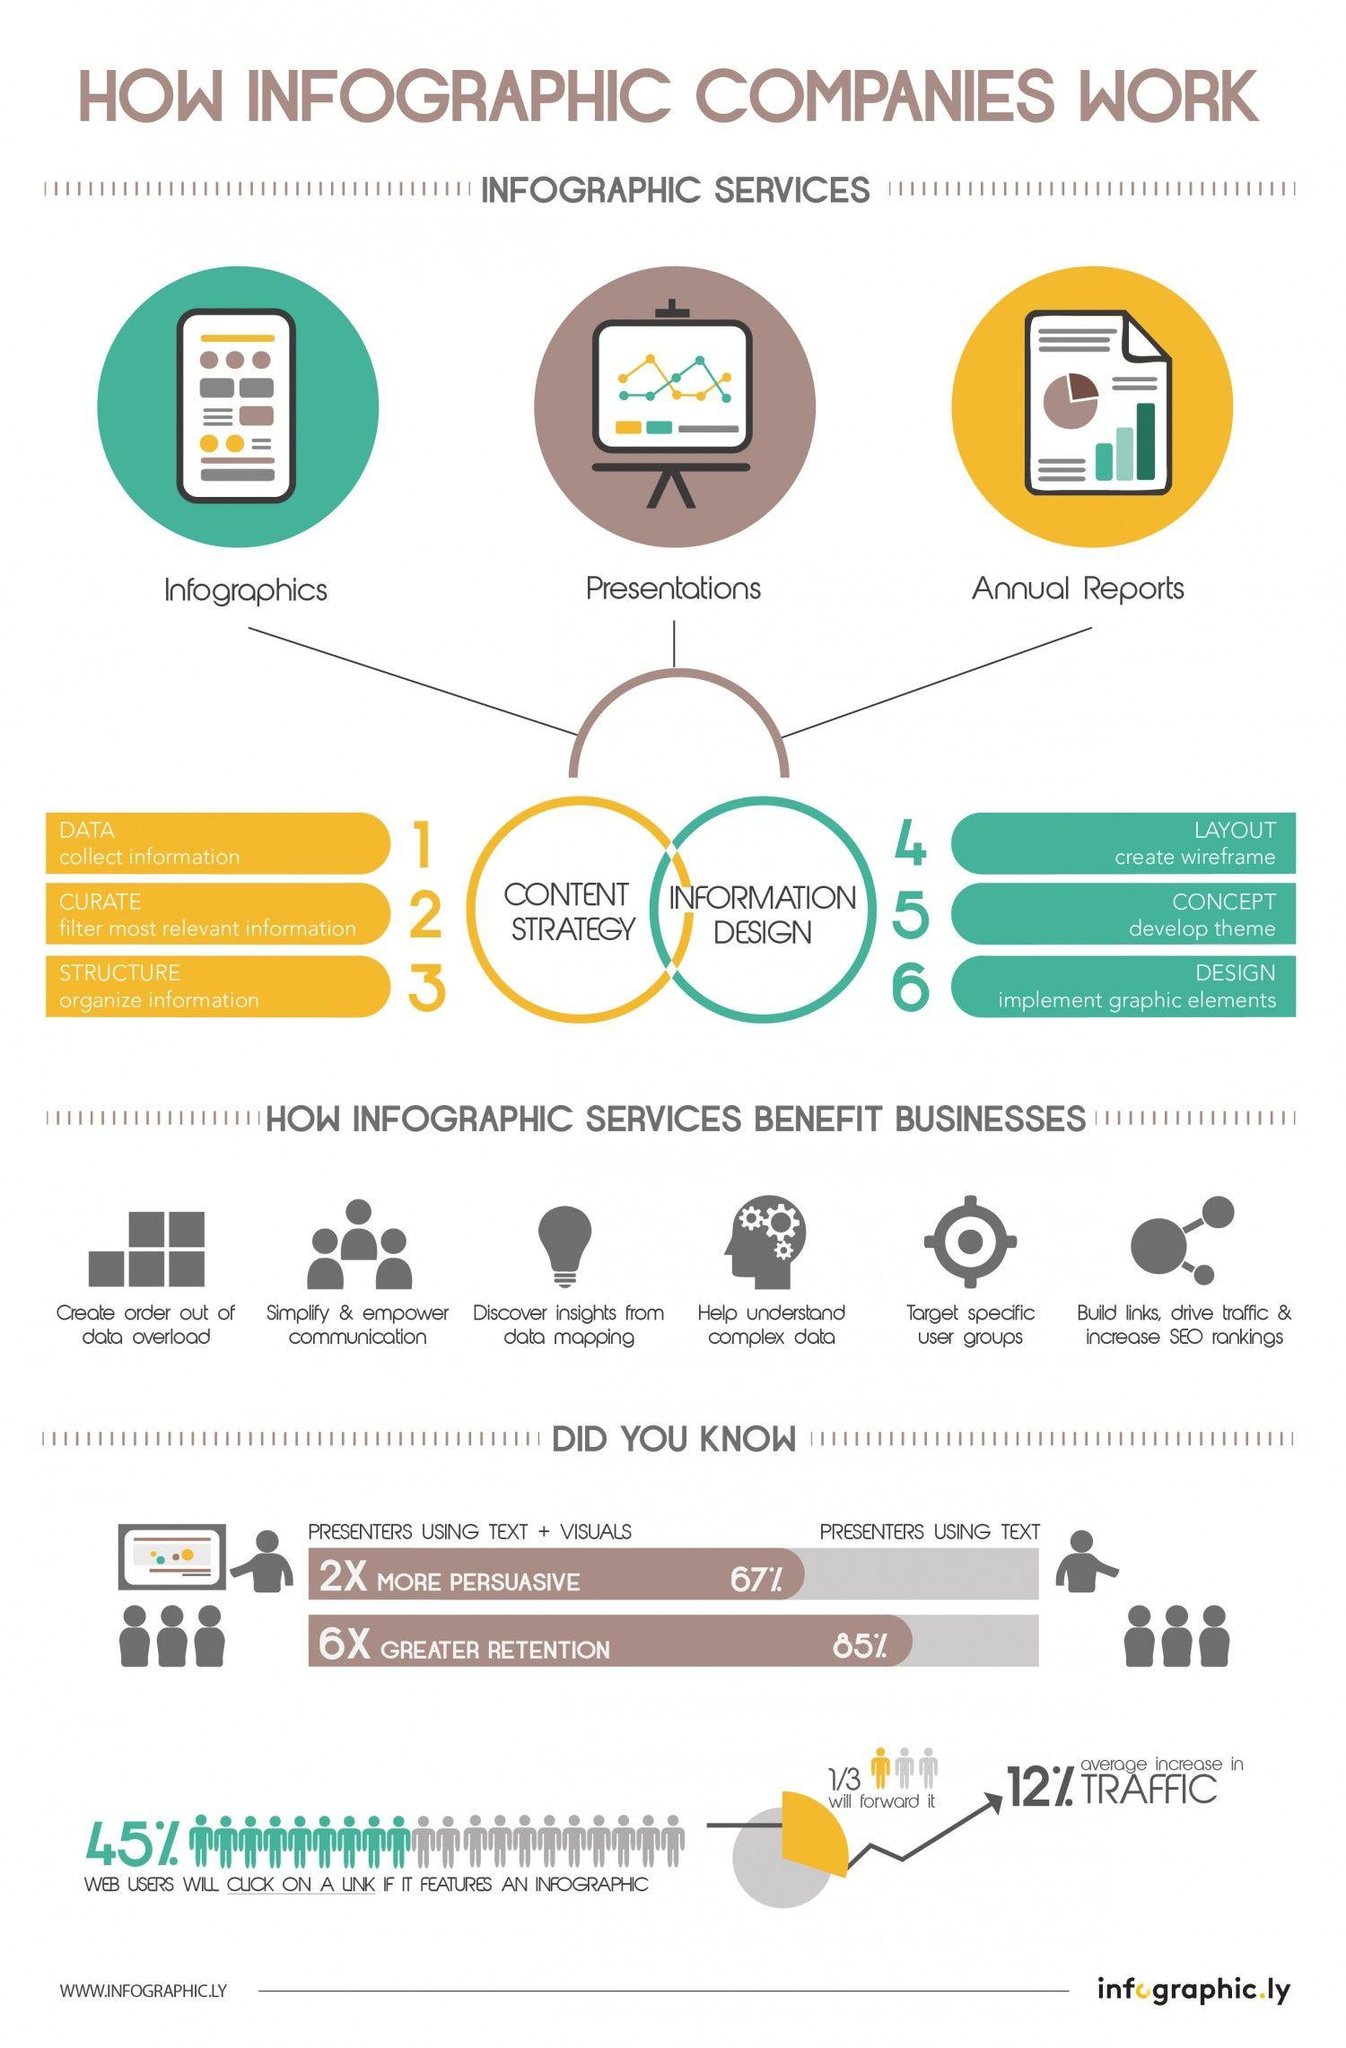Give some essential details in this illustration. According to the data presented, 33% of people use text only to display information. Information design is composed of three components: layout, concept, and design. 